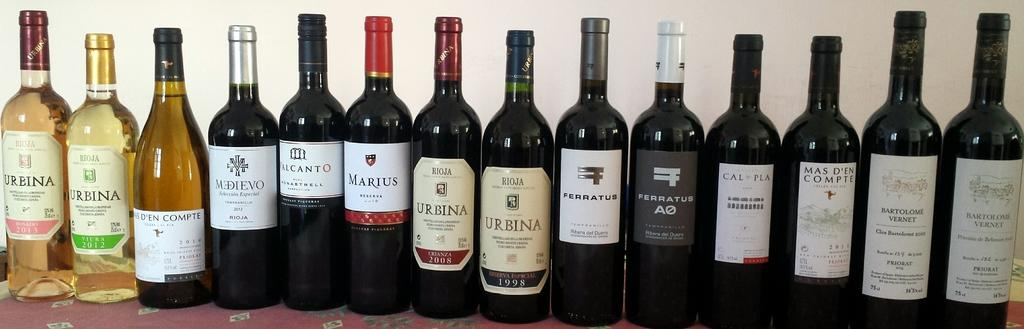What objects are present in the image? There are bottles in the image. What can be seen on the bottles? The bottles have labels on them. What is inside the bottles? The bottles are filled with liquid. What type of fang can be seen protruding from the bottle in the image? There is no fang present in the image; the bottles have labels and contain liquid. 